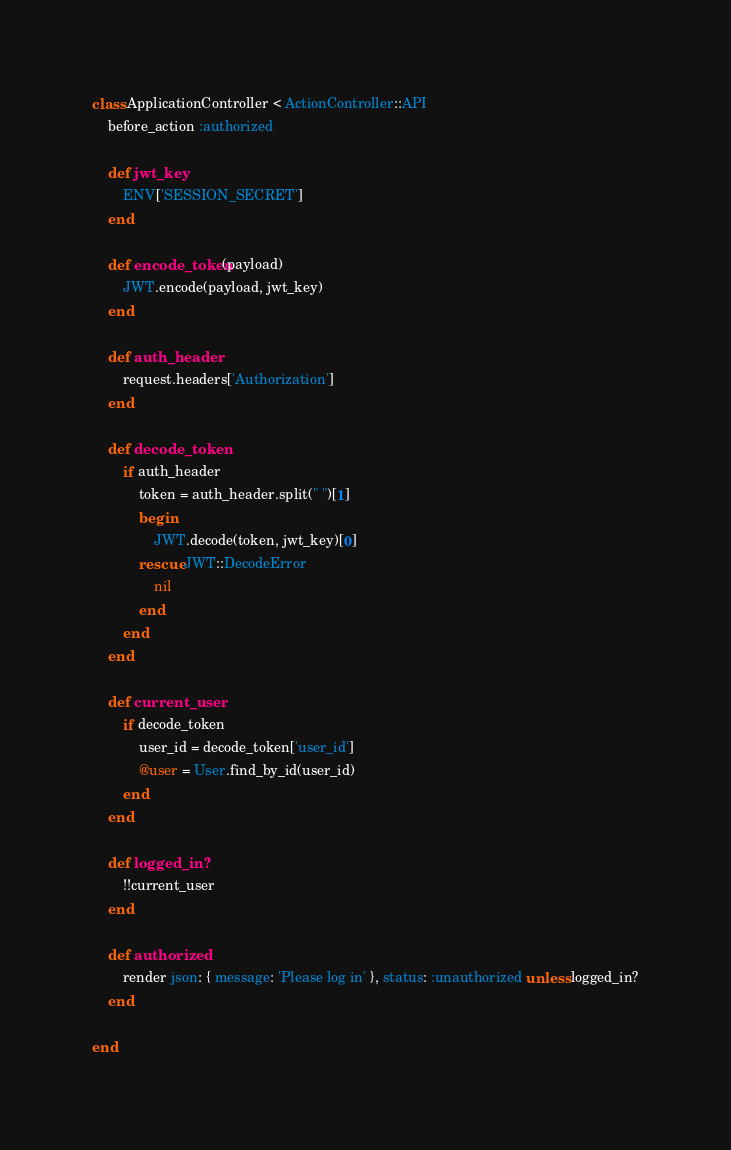<code> <loc_0><loc_0><loc_500><loc_500><_Ruby_>class ApplicationController < ActionController::API
    before_action :authorized
   
    def jwt_key
        ENV['SESSION_SECRET']
    end

    def encode_token(payload)
        JWT.encode(payload, jwt_key)
    end

    def auth_header
        request.headers['Authorization']
    end

    def decode_token
        if auth_header
            token = auth_header.split(" ")[1]
            begin
                JWT.decode(token, jwt_key)[0]
            rescue JWT::DecodeError
                nil
            end
        end
    end

    def current_user
        if decode_token
            user_id = decode_token['user_id']
            @user = User.find_by_id(user_id)
        end
    end

    def logged_in?
        !!current_user
    end

    def authorized
        render json: { message: 'Please log in' }, status: :unauthorized unless logged_in?
    end

end
</code> 